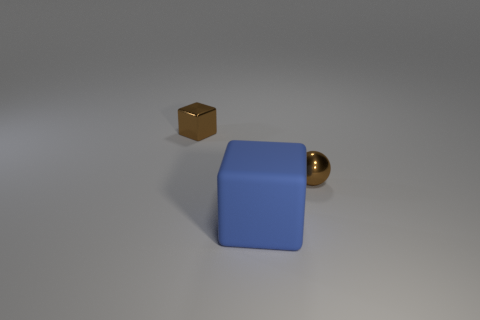Is there any other thing that has the same size as the blue object?
Provide a succinct answer. No. Is the blue block the same size as the brown ball?
Provide a short and direct response. No. Are there more metal objects than big blue things?
Give a very brief answer. Yes. How many other things are there of the same color as the tiny shiny block?
Your answer should be very brief. 1. How many objects are either big rubber cubes or red cylinders?
Keep it short and to the point. 1. Do the tiny brown object that is on the right side of the blue rubber object and the matte object have the same shape?
Offer a terse response. No. There is a metal thing right of the small object that is on the left side of the blue rubber object; what color is it?
Provide a short and direct response. Brown. Is the number of shiny blocks less than the number of yellow shiny spheres?
Ensure brevity in your answer.  No. Are there any brown balls made of the same material as the blue thing?
Your answer should be very brief. No. Does the large blue rubber thing have the same shape as the brown thing to the left of the large blue thing?
Offer a terse response. Yes. 